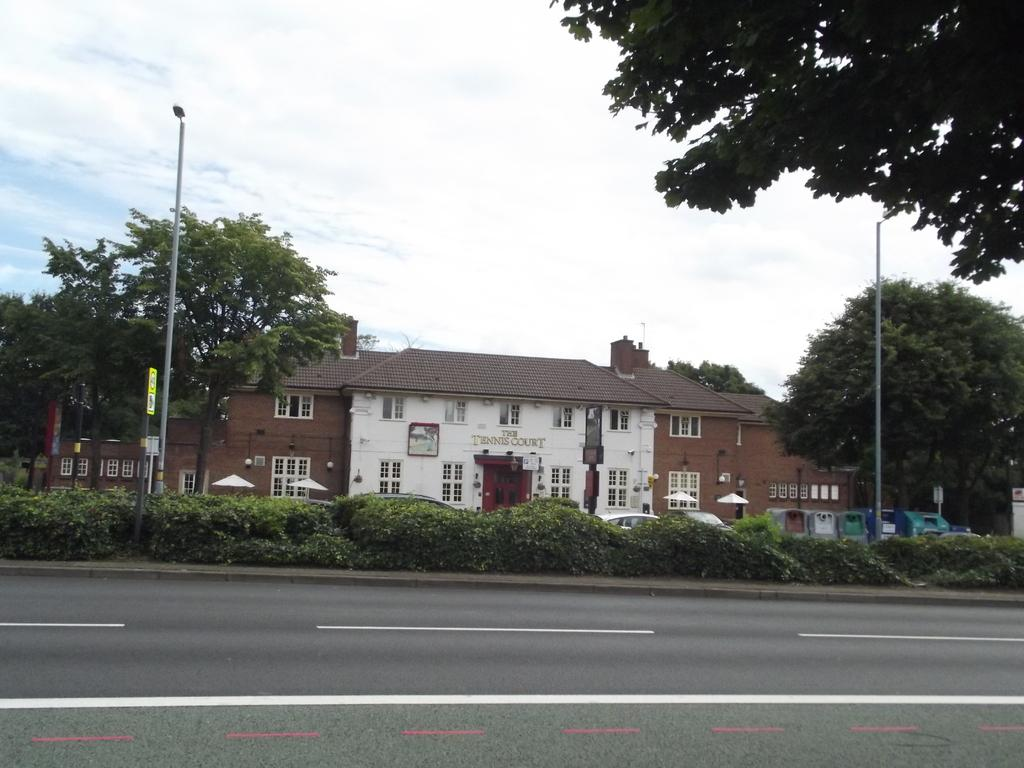What is the main feature of the image? There is a road in the image. What can be seen in the background of the image? In the background, there are plants, poles, houses, trees, and the sky. Can you describe the tree in the top right corner of the image? Yes, there is a tree in the top right corner of the image. What type of blade is being used by the group in the image? There is no group or blade present in the image. What thing is being used to cut the tree in the image? There is no tree being cut in the image, and no cutting tool is visible. 